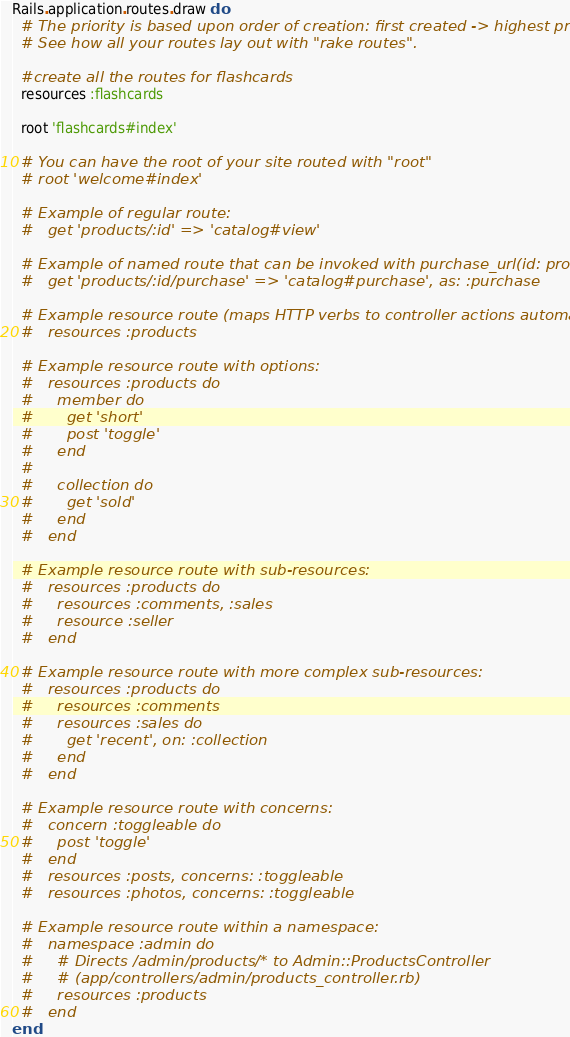<code> <loc_0><loc_0><loc_500><loc_500><_Ruby_>Rails.application.routes.draw do
  # The priority is based upon order of creation: first created -> highest priority.
  # See how all your routes lay out with "rake routes".

  #create all the routes for flashcards
  resources :flashcards

  root 'flashcards#index'

  # You can have the root of your site routed with "root"
  # root 'welcome#index'

  # Example of regular route:
  #   get 'products/:id' => 'catalog#view'

  # Example of named route that can be invoked with purchase_url(id: product.id)
  #   get 'products/:id/purchase' => 'catalog#purchase', as: :purchase

  # Example resource route (maps HTTP verbs to controller actions automatically):
  #   resources :products

  # Example resource route with options:
  #   resources :products do
  #     member do
  #       get 'short'
  #       post 'toggle'
  #     end
  #
  #     collection do
  #       get 'sold'
  #     end
  #   end

  # Example resource route with sub-resources:
  #   resources :products do
  #     resources :comments, :sales
  #     resource :seller
  #   end

  # Example resource route with more complex sub-resources:
  #   resources :products do
  #     resources :comments
  #     resources :sales do
  #       get 'recent', on: :collection
  #     end
  #   end

  # Example resource route with concerns:
  #   concern :toggleable do
  #     post 'toggle'
  #   end
  #   resources :posts, concerns: :toggleable
  #   resources :photos, concerns: :toggleable

  # Example resource route within a namespace:
  #   namespace :admin do
  #     # Directs /admin/products/* to Admin::ProductsController
  #     # (app/controllers/admin/products_controller.rb)
  #     resources :products
  #   end
end
</code> 